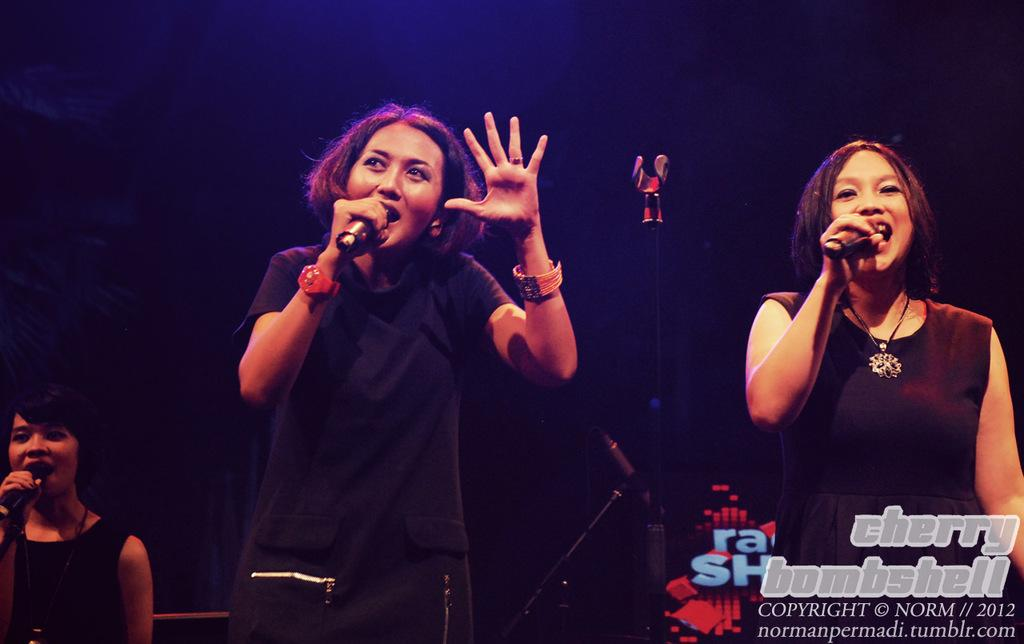How many women are in the image? There are three women in the image. What are the women doing in the image? The women are standing and holding a mic. What are the women wearing in the image? All the women are wearing black dresses. What advice are the women giving to the children in the image? There are no children present in the image, so no advice can be given to them. What type of soda is being served at the event in the image? There is no mention of soda or an event in the image. 